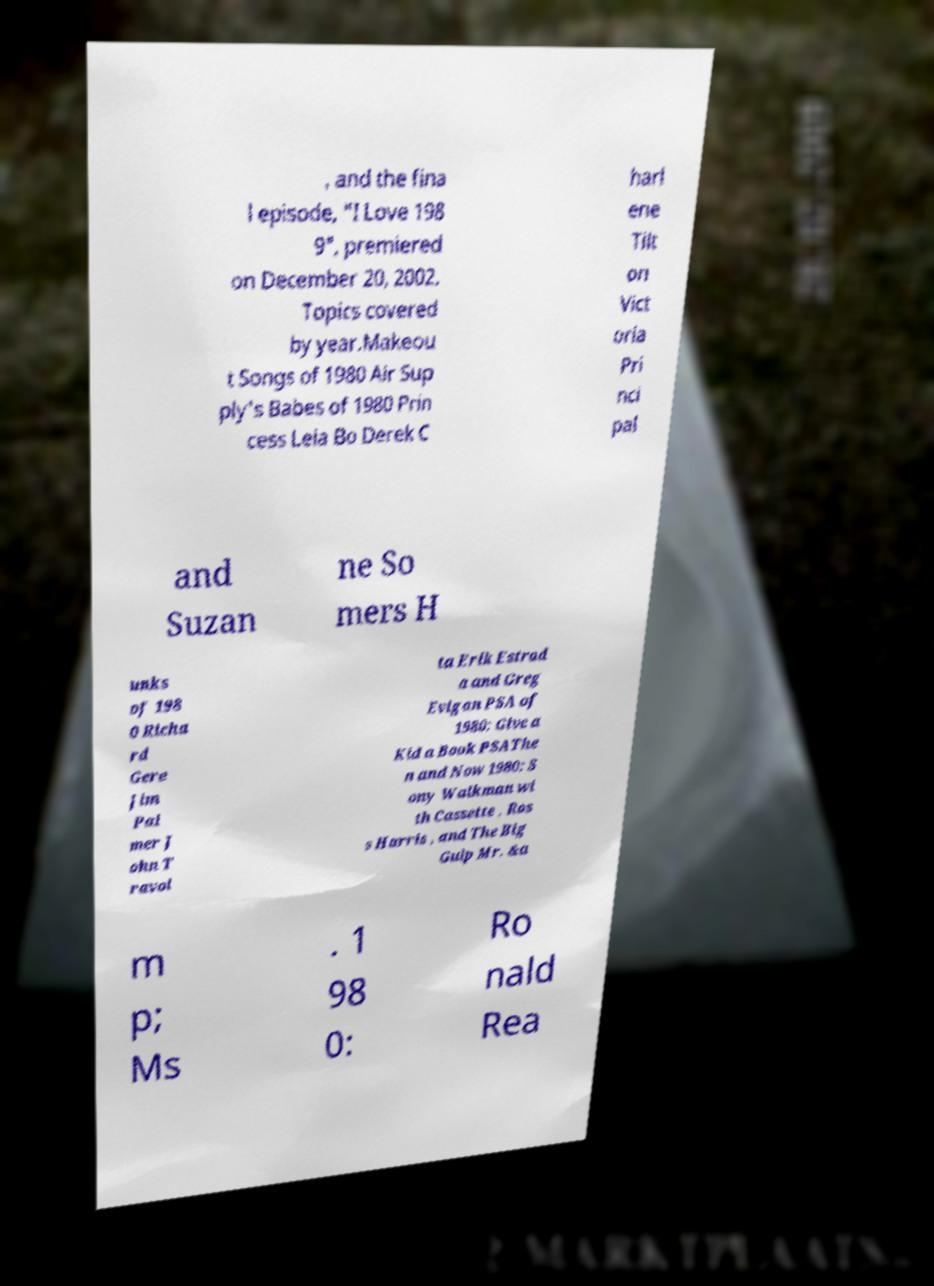Could you assist in decoding the text presented in this image and type it out clearly? , and the fina l episode, "I Love 198 9", premiered on December 20, 2002. Topics covered by year.Makeou t Songs of 1980 Air Sup ply's Babes of 1980 Prin cess Leia Bo Derek C harl ene Tilt on Vict oria Pri nci pal and Suzan ne So mers H unks of 198 0 Richa rd Gere Jim Pal mer J ohn T ravol ta Erik Estrad a and Greg Evigan PSA of 1980: Give a Kid a Book PSAThe n and Now 1980: S ony Walkman wi th Cassette , Ros s Harris , and The Big Gulp Mr. &a m p; Ms . 1 98 0: Ro nald Rea 